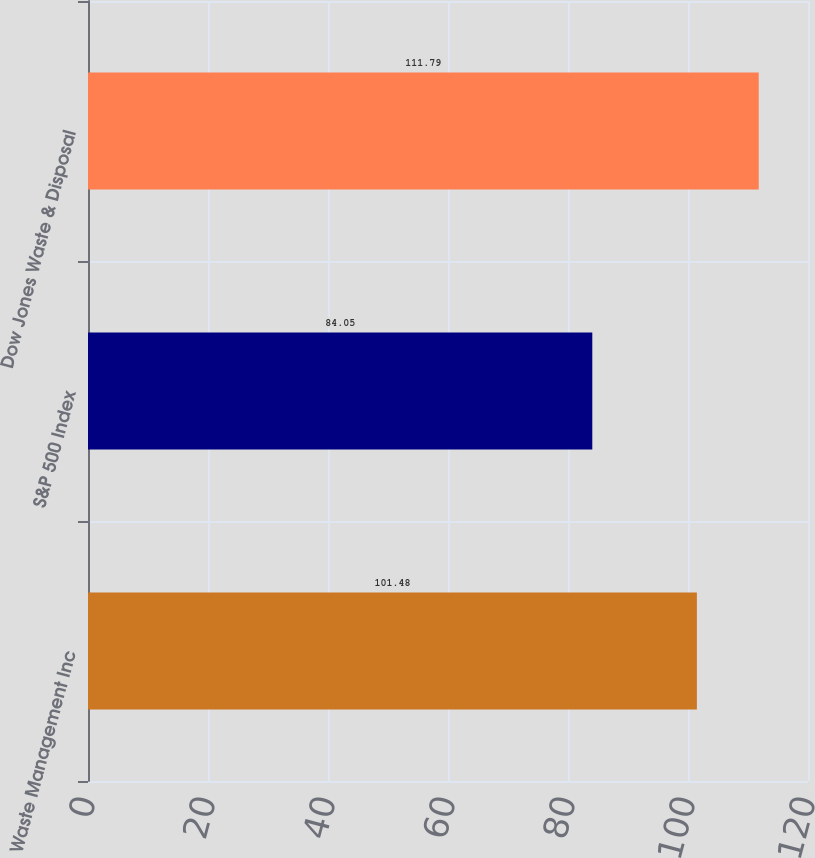Convert chart to OTSL. <chart><loc_0><loc_0><loc_500><loc_500><bar_chart><fcel>Waste Management Inc<fcel>S&P 500 Index<fcel>Dow Jones Waste & Disposal<nl><fcel>101.48<fcel>84.05<fcel>111.79<nl></chart> 